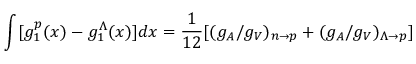Convert formula to latex. <formula><loc_0><loc_0><loc_500><loc_500>\int [ g _ { 1 } ^ { p } ( x ) - g _ { 1 } ^ { \Lambda } ( x ) ] d x = { \frac { 1 } { 1 2 } } [ ( g _ { A } / g _ { V } ) _ { n \rightarrow p } + ( g _ { A } / g _ { V } ) _ { \Lambda \rightarrow p } ]</formula> 